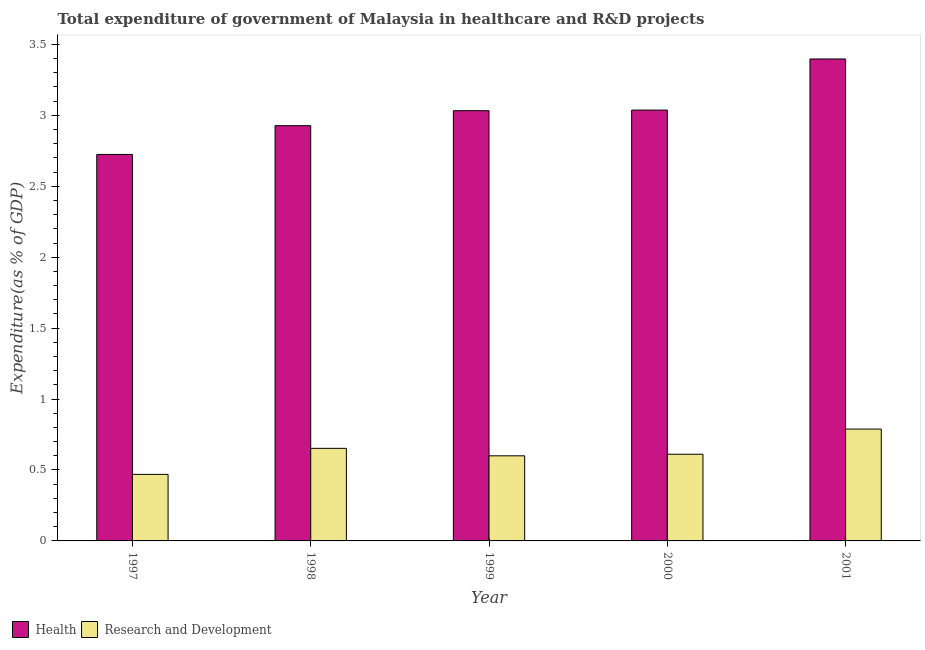How many different coloured bars are there?
Give a very brief answer. 2. Are the number of bars per tick equal to the number of legend labels?
Provide a succinct answer. Yes. Are the number of bars on each tick of the X-axis equal?
Make the answer very short. Yes. How many bars are there on the 3rd tick from the left?
Provide a succinct answer. 2. In how many cases, is the number of bars for a given year not equal to the number of legend labels?
Your answer should be compact. 0. What is the expenditure in r&d in 2000?
Keep it short and to the point. 0.61. Across all years, what is the maximum expenditure in healthcare?
Provide a short and direct response. 3.4. Across all years, what is the minimum expenditure in healthcare?
Your answer should be very brief. 2.72. In which year was the expenditure in healthcare maximum?
Provide a succinct answer. 2001. What is the total expenditure in healthcare in the graph?
Give a very brief answer. 15.12. What is the difference between the expenditure in healthcare in 2000 and that in 2001?
Your answer should be compact. -0.36. What is the difference between the expenditure in healthcare in 1998 and the expenditure in r&d in 1999?
Offer a very short reply. -0.11. What is the average expenditure in healthcare per year?
Ensure brevity in your answer.  3.02. In the year 1999, what is the difference between the expenditure in r&d and expenditure in healthcare?
Keep it short and to the point. 0. What is the ratio of the expenditure in r&d in 1998 to that in 2000?
Your response must be concise. 1.07. Is the expenditure in healthcare in 1998 less than that in 2001?
Offer a very short reply. Yes. What is the difference between the highest and the second highest expenditure in r&d?
Your response must be concise. 0.14. What is the difference between the highest and the lowest expenditure in healthcare?
Your answer should be very brief. 0.67. In how many years, is the expenditure in healthcare greater than the average expenditure in healthcare taken over all years?
Give a very brief answer. 3. What does the 1st bar from the left in 2001 represents?
Provide a succinct answer. Health. What does the 2nd bar from the right in 1999 represents?
Offer a terse response. Health. What is the difference between two consecutive major ticks on the Y-axis?
Ensure brevity in your answer.  0.5. Are the values on the major ticks of Y-axis written in scientific E-notation?
Offer a terse response. No. Does the graph contain any zero values?
Your answer should be very brief. No. Does the graph contain grids?
Provide a succinct answer. No. Where does the legend appear in the graph?
Make the answer very short. Bottom left. How many legend labels are there?
Make the answer very short. 2. How are the legend labels stacked?
Offer a very short reply. Horizontal. What is the title of the graph?
Provide a succinct answer. Total expenditure of government of Malaysia in healthcare and R&D projects. What is the label or title of the Y-axis?
Offer a very short reply. Expenditure(as % of GDP). What is the Expenditure(as % of GDP) of Health in 1997?
Give a very brief answer. 2.72. What is the Expenditure(as % of GDP) in Research and Development in 1997?
Your answer should be very brief. 0.47. What is the Expenditure(as % of GDP) in Health in 1998?
Make the answer very short. 2.93. What is the Expenditure(as % of GDP) in Research and Development in 1998?
Offer a terse response. 0.65. What is the Expenditure(as % of GDP) of Health in 1999?
Your response must be concise. 3.03. What is the Expenditure(as % of GDP) in Research and Development in 1999?
Offer a very short reply. 0.6. What is the Expenditure(as % of GDP) of Health in 2000?
Offer a very short reply. 3.04. What is the Expenditure(as % of GDP) in Research and Development in 2000?
Make the answer very short. 0.61. What is the Expenditure(as % of GDP) of Health in 2001?
Give a very brief answer. 3.4. What is the Expenditure(as % of GDP) in Research and Development in 2001?
Ensure brevity in your answer.  0.79. Across all years, what is the maximum Expenditure(as % of GDP) in Health?
Your answer should be compact. 3.4. Across all years, what is the maximum Expenditure(as % of GDP) of Research and Development?
Ensure brevity in your answer.  0.79. Across all years, what is the minimum Expenditure(as % of GDP) of Health?
Your answer should be very brief. 2.72. Across all years, what is the minimum Expenditure(as % of GDP) of Research and Development?
Your answer should be compact. 0.47. What is the total Expenditure(as % of GDP) of Health in the graph?
Your answer should be compact. 15.12. What is the total Expenditure(as % of GDP) of Research and Development in the graph?
Offer a very short reply. 3.12. What is the difference between the Expenditure(as % of GDP) in Health in 1997 and that in 1998?
Make the answer very short. -0.2. What is the difference between the Expenditure(as % of GDP) of Research and Development in 1997 and that in 1998?
Your answer should be compact. -0.18. What is the difference between the Expenditure(as % of GDP) of Health in 1997 and that in 1999?
Your answer should be compact. -0.31. What is the difference between the Expenditure(as % of GDP) in Research and Development in 1997 and that in 1999?
Provide a short and direct response. -0.13. What is the difference between the Expenditure(as % of GDP) in Health in 1997 and that in 2000?
Offer a terse response. -0.31. What is the difference between the Expenditure(as % of GDP) of Research and Development in 1997 and that in 2000?
Give a very brief answer. -0.14. What is the difference between the Expenditure(as % of GDP) in Health in 1997 and that in 2001?
Make the answer very short. -0.67. What is the difference between the Expenditure(as % of GDP) of Research and Development in 1997 and that in 2001?
Make the answer very short. -0.32. What is the difference between the Expenditure(as % of GDP) in Health in 1998 and that in 1999?
Offer a terse response. -0.11. What is the difference between the Expenditure(as % of GDP) in Research and Development in 1998 and that in 1999?
Provide a short and direct response. 0.05. What is the difference between the Expenditure(as % of GDP) in Health in 1998 and that in 2000?
Keep it short and to the point. -0.11. What is the difference between the Expenditure(as % of GDP) in Research and Development in 1998 and that in 2000?
Offer a very short reply. 0.04. What is the difference between the Expenditure(as % of GDP) in Health in 1998 and that in 2001?
Provide a short and direct response. -0.47. What is the difference between the Expenditure(as % of GDP) of Research and Development in 1998 and that in 2001?
Offer a terse response. -0.14. What is the difference between the Expenditure(as % of GDP) of Health in 1999 and that in 2000?
Your answer should be compact. -0. What is the difference between the Expenditure(as % of GDP) in Research and Development in 1999 and that in 2000?
Make the answer very short. -0.01. What is the difference between the Expenditure(as % of GDP) of Health in 1999 and that in 2001?
Your answer should be compact. -0.36. What is the difference between the Expenditure(as % of GDP) in Research and Development in 1999 and that in 2001?
Your answer should be compact. -0.19. What is the difference between the Expenditure(as % of GDP) of Health in 2000 and that in 2001?
Provide a succinct answer. -0.36. What is the difference between the Expenditure(as % of GDP) in Research and Development in 2000 and that in 2001?
Make the answer very short. -0.18. What is the difference between the Expenditure(as % of GDP) of Health in 1997 and the Expenditure(as % of GDP) of Research and Development in 1998?
Offer a very short reply. 2.07. What is the difference between the Expenditure(as % of GDP) in Health in 1997 and the Expenditure(as % of GDP) in Research and Development in 1999?
Provide a succinct answer. 2.12. What is the difference between the Expenditure(as % of GDP) in Health in 1997 and the Expenditure(as % of GDP) in Research and Development in 2000?
Make the answer very short. 2.11. What is the difference between the Expenditure(as % of GDP) of Health in 1997 and the Expenditure(as % of GDP) of Research and Development in 2001?
Offer a terse response. 1.94. What is the difference between the Expenditure(as % of GDP) in Health in 1998 and the Expenditure(as % of GDP) in Research and Development in 1999?
Your response must be concise. 2.33. What is the difference between the Expenditure(as % of GDP) in Health in 1998 and the Expenditure(as % of GDP) in Research and Development in 2000?
Your response must be concise. 2.32. What is the difference between the Expenditure(as % of GDP) in Health in 1998 and the Expenditure(as % of GDP) in Research and Development in 2001?
Your response must be concise. 2.14. What is the difference between the Expenditure(as % of GDP) in Health in 1999 and the Expenditure(as % of GDP) in Research and Development in 2000?
Make the answer very short. 2.42. What is the difference between the Expenditure(as % of GDP) in Health in 1999 and the Expenditure(as % of GDP) in Research and Development in 2001?
Ensure brevity in your answer.  2.24. What is the difference between the Expenditure(as % of GDP) in Health in 2000 and the Expenditure(as % of GDP) in Research and Development in 2001?
Ensure brevity in your answer.  2.25. What is the average Expenditure(as % of GDP) of Health per year?
Offer a terse response. 3.02. What is the average Expenditure(as % of GDP) of Research and Development per year?
Make the answer very short. 0.62. In the year 1997, what is the difference between the Expenditure(as % of GDP) in Health and Expenditure(as % of GDP) in Research and Development?
Your answer should be very brief. 2.26. In the year 1998, what is the difference between the Expenditure(as % of GDP) in Health and Expenditure(as % of GDP) in Research and Development?
Give a very brief answer. 2.27. In the year 1999, what is the difference between the Expenditure(as % of GDP) of Health and Expenditure(as % of GDP) of Research and Development?
Offer a terse response. 2.43. In the year 2000, what is the difference between the Expenditure(as % of GDP) of Health and Expenditure(as % of GDP) of Research and Development?
Ensure brevity in your answer.  2.43. In the year 2001, what is the difference between the Expenditure(as % of GDP) in Health and Expenditure(as % of GDP) in Research and Development?
Provide a succinct answer. 2.61. What is the ratio of the Expenditure(as % of GDP) in Health in 1997 to that in 1998?
Keep it short and to the point. 0.93. What is the ratio of the Expenditure(as % of GDP) of Research and Development in 1997 to that in 1998?
Make the answer very short. 0.72. What is the ratio of the Expenditure(as % of GDP) of Health in 1997 to that in 1999?
Ensure brevity in your answer.  0.9. What is the ratio of the Expenditure(as % of GDP) of Research and Development in 1997 to that in 1999?
Provide a short and direct response. 0.78. What is the ratio of the Expenditure(as % of GDP) of Health in 1997 to that in 2000?
Give a very brief answer. 0.9. What is the ratio of the Expenditure(as % of GDP) in Research and Development in 1997 to that in 2000?
Your answer should be very brief. 0.77. What is the ratio of the Expenditure(as % of GDP) in Health in 1997 to that in 2001?
Provide a succinct answer. 0.8. What is the ratio of the Expenditure(as % of GDP) of Research and Development in 1997 to that in 2001?
Offer a terse response. 0.59. What is the ratio of the Expenditure(as % of GDP) in Health in 1998 to that in 1999?
Your answer should be compact. 0.97. What is the ratio of the Expenditure(as % of GDP) of Research and Development in 1998 to that in 1999?
Your answer should be very brief. 1.09. What is the ratio of the Expenditure(as % of GDP) in Health in 1998 to that in 2000?
Provide a succinct answer. 0.96. What is the ratio of the Expenditure(as % of GDP) in Research and Development in 1998 to that in 2000?
Your answer should be compact. 1.07. What is the ratio of the Expenditure(as % of GDP) of Health in 1998 to that in 2001?
Offer a very short reply. 0.86. What is the ratio of the Expenditure(as % of GDP) of Research and Development in 1998 to that in 2001?
Offer a very short reply. 0.83. What is the ratio of the Expenditure(as % of GDP) of Health in 1999 to that in 2000?
Provide a succinct answer. 1. What is the ratio of the Expenditure(as % of GDP) in Research and Development in 1999 to that in 2000?
Your answer should be compact. 0.98. What is the ratio of the Expenditure(as % of GDP) of Health in 1999 to that in 2001?
Give a very brief answer. 0.89. What is the ratio of the Expenditure(as % of GDP) in Research and Development in 1999 to that in 2001?
Ensure brevity in your answer.  0.76. What is the ratio of the Expenditure(as % of GDP) in Health in 2000 to that in 2001?
Offer a very short reply. 0.89. What is the ratio of the Expenditure(as % of GDP) in Research and Development in 2000 to that in 2001?
Keep it short and to the point. 0.78. What is the difference between the highest and the second highest Expenditure(as % of GDP) of Health?
Your answer should be compact. 0.36. What is the difference between the highest and the second highest Expenditure(as % of GDP) of Research and Development?
Your response must be concise. 0.14. What is the difference between the highest and the lowest Expenditure(as % of GDP) of Health?
Ensure brevity in your answer.  0.67. What is the difference between the highest and the lowest Expenditure(as % of GDP) of Research and Development?
Offer a terse response. 0.32. 